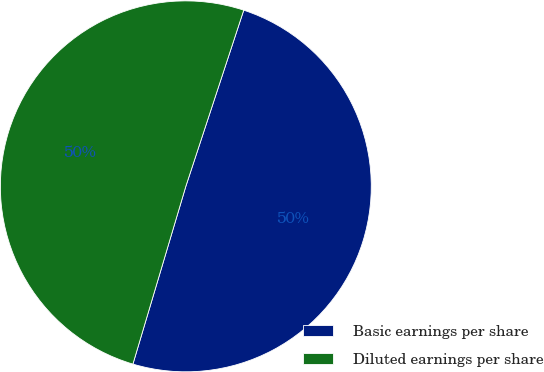Convert chart to OTSL. <chart><loc_0><loc_0><loc_500><loc_500><pie_chart><fcel>Basic earnings per share<fcel>Diluted earnings per share<nl><fcel>49.55%<fcel>50.45%<nl></chart> 